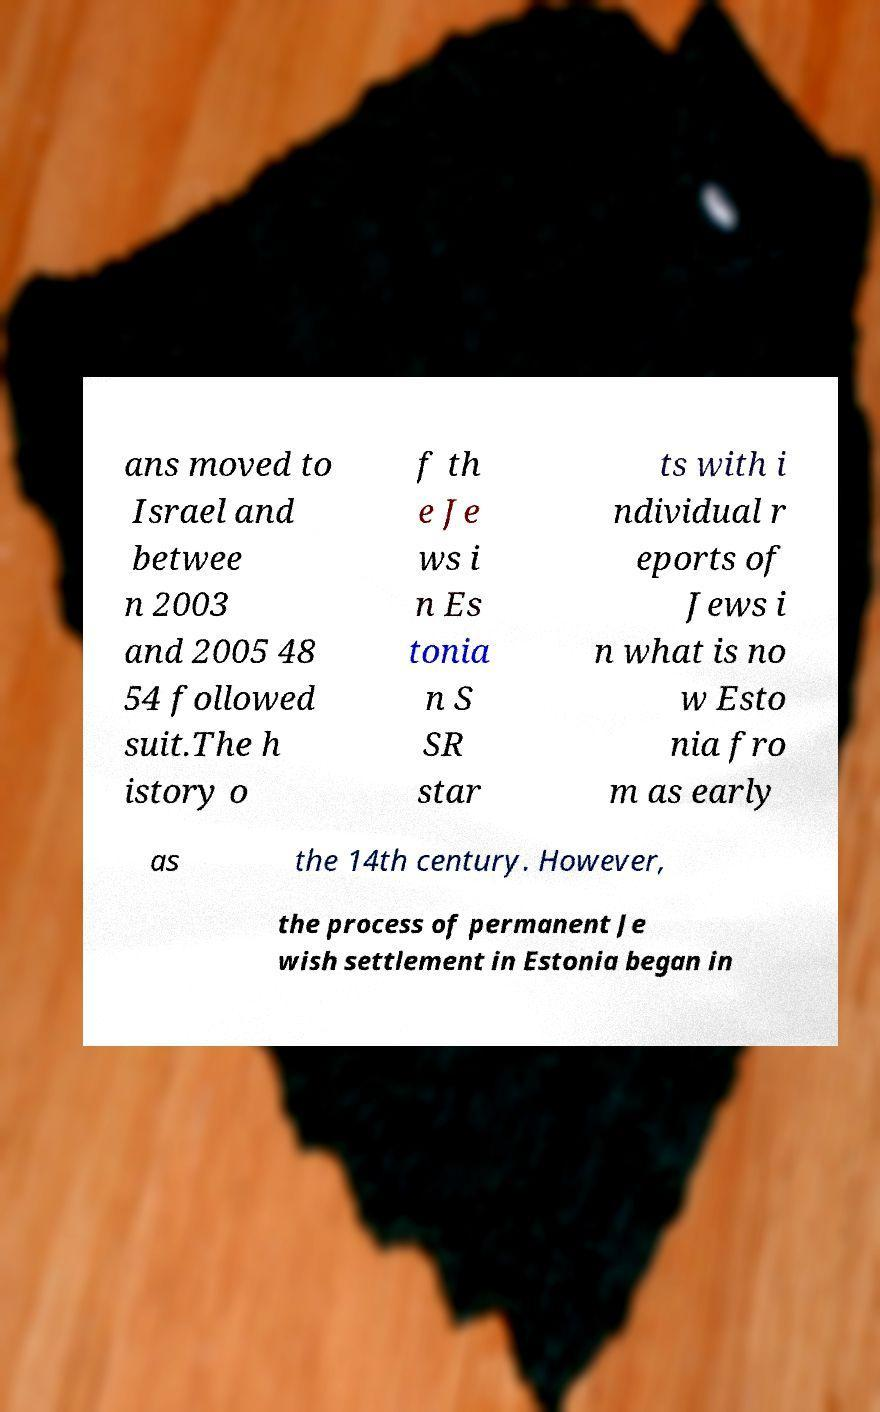There's text embedded in this image that I need extracted. Can you transcribe it verbatim? ans moved to Israel and betwee n 2003 and 2005 48 54 followed suit.The h istory o f th e Je ws i n Es tonia n S SR star ts with i ndividual r eports of Jews i n what is no w Esto nia fro m as early as the 14th century. However, the process of permanent Je wish settlement in Estonia began in 